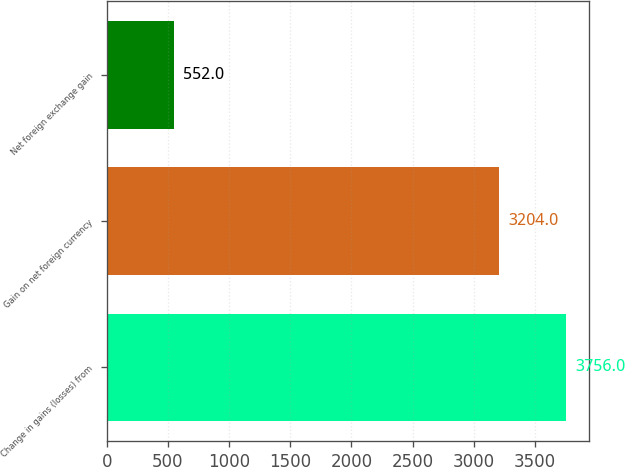Convert chart. <chart><loc_0><loc_0><loc_500><loc_500><bar_chart><fcel>Change in gains (losses) from<fcel>Gain on net foreign currency<fcel>Net foreign exchange gain<nl><fcel>3756<fcel>3204<fcel>552<nl></chart> 